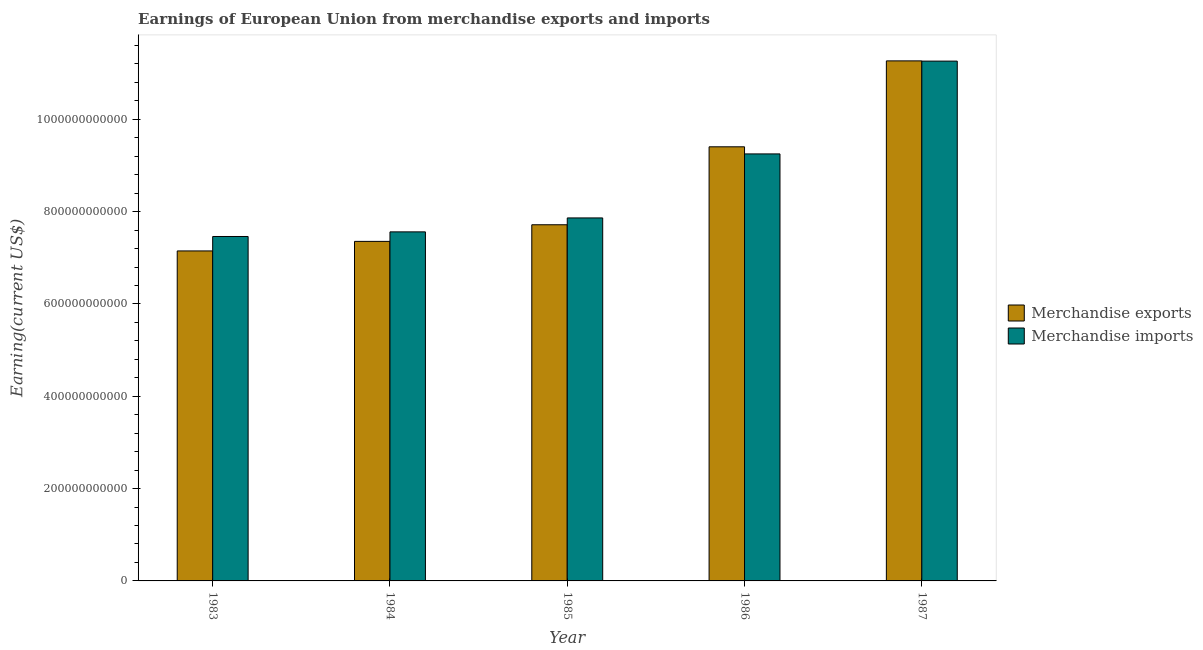Are the number of bars on each tick of the X-axis equal?
Your response must be concise. Yes. How many bars are there on the 4th tick from the left?
Provide a succinct answer. 2. What is the label of the 2nd group of bars from the left?
Keep it short and to the point. 1984. In how many cases, is the number of bars for a given year not equal to the number of legend labels?
Your answer should be very brief. 0. What is the earnings from merchandise imports in 1987?
Offer a very short reply. 1.13e+12. Across all years, what is the maximum earnings from merchandise exports?
Your answer should be very brief. 1.13e+12. Across all years, what is the minimum earnings from merchandise exports?
Keep it short and to the point. 7.15e+11. In which year was the earnings from merchandise exports maximum?
Make the answer very short. 1987. What is the total earnings from merchandise exports in the graph?
Keep it short and to the point. 4.29e+12. What is the difference between the earnings from merchandise imports in 1983 and that in 1985?
Ensure brevity in your answer.  -4.02e+1. What is the difference between the earnings from merchandise exports in 1985 and the earnings from merchandise imports in 1987?
Keep it short and to the point. -3.55e+11. What is the average earnings from merchandise imports per year?
Make the answer very short. 8.68e+11. In the year 1984, what is the difference between the earnings from merchandise exports and earnings from merchandise imports?
Your answer should be very brief. 0. In how many years, is the earnings from merchandise imports greater than 160000000000 US$?
Your answer should be very brief. 5. What is the ratio of the earnings from merchandise imports in 1983 to that in 1986?
Provide a succinct answer. 0.81. Is the earnings from merchandise exports in 1983 less than that in 1984?
Ensure brevity in your answer.  Yes. What is the difference between the highest and the second highest earnings from merchandise exports?
Give a very brief answer. 1.86e+11. What is the difference between the highest and the lowest earnings from merchandise exports?
Provide a short and direct response. 4.12e+11. In how many years, is the earnings from merchandise imports greater than the average earnings from merchandise imports taken over all years?
Offer a terse response. 2. What does the 2nd bar from the left in 1985 represents?
Offer a terse response. Merchandise imports. How many bars are there?
Offer a terse response. 10. What is the difference between two consecutive major ticks on the Y-axis?
Provide a succinct answer. 2.00e+11. Are the values on the major ticks of Y-axis written in scientific E-notation?
Make the answer very short. No. Where does the legend appear in the graph?
Offer a terse response. Center right. How are the legend labels stacked?
Your answer should be very brief. Vertical. What is the title of the graph?
Your response must be concise. Earnings of European Union from merchandise exports and imports. What is the label or title of the X-axis?
Provide a succinct answer. Year. What is the label or title of the Y-axis?
Provide a short and direct response. Earning(current US$). What is the Earning(current US$) in Merchandise exports in 1983?
Offer a very short reply. 7.15e+11. What is the Earning(current US$) in Merchandise imports in 1983?
Your answer should be compact. 7.46e+11. What is the Earning(current US$) of Merchandise exports in 1984?
Give a very brief answer. 7.36e+11. What is the Earning(current US$) of Merchandise imports in 1984?
Make the answer very short. 7.56e+11. What is the Earning(current US$) of Merchandise exports in 1985?
Offer a very short reply. 7.72e+11. What is the Earning(current US$) of Merchandise imports in 1985?
Offer a terse response. 7.86e+11. What is the Earning(current US$) of Merchandise exports in 1986?
Keep it short and to the point. 9.40e+11. What is the Earning(current US$) in Merchandise imports in 1986?
Keep it short and to the point. 9.25e+11. What is the Earning(current US$) of Merchandise exports in 1987?
Offer a very short reply. 1.13e+12. What is the Earning(current US$) of Merchandise imports in 1987?
Keep it short and to the point. 1.13e+12. Across all years, what is the maximum Earning(current US$) in Merchandise exports?
Your answer should be compact. 1.13e+12. Across all years, what is the maximum Earning(current US$) in Merchandise imports?
Provide a succinct answer. 1.13e+12. Across all years, what is the minimum Earning(current US$) of Merchandise exports?
Give a very brief answer. 7.15e+11. Across all years, what is the minimum Earning(current US$) of Merchandise imports?
Offer a very short reply. 7.46e+11. What is the total Earning(current US$) in Merchandise exports in the graph?
Your response must be concise. 4.29e+12. What is the total Earning(current US$) in Merchandise imports in the graph?
Offer a terse response. 4.34e+12. What is the difference between the Earning(current US$) in Merchandise exports in 1983 and that in 1984?
Provide a short and direct response. -2.07e+1. What is the difference between the Earning(current US$) of Merchandise imports in 1983 and that in 1984?
Your response must be concise. -1.00e+1. What is the difference between the Earning(current US$) in Merchandise exports in 1983 and that in 1985?
Provide a short and direct response. -5.67e+1. What is the difference between the Earning(current US$) in Merchandise imports in 1983 and that in 1985?
Offer a terse response. -4.02e+1. What is the difference between the Earning(current US$) in Merchandise exports in 1983 and that in 1986?
Give a very brief answer. -2.26e+11. What is the difference between the Earning(current US$) of Merchandise imports in 1983 and that in 1986?
Provide a succinct answer. -1.79e+11. What is the difference between the Earning(current US$) in Merchandise exports in 1983 and that in 1987?
Ensure brevity in your answer.  -4.12e+11. What is the difference between the Earning(current US$) of Merchandise imports in 1983 and that in 1987?
Give a very brief answer. -3.80e+11. What is the difference between the Earning(current US$) of Merchandise exports in 1984 and that in 1985?
Your answer should be compact. -3.60e+1. What is the difference between the Earning(current US$) of Merchandise imports in 1984 and that in 1985?
Your answer should be compact. -3.02e+1. What is the difference between the Earning(current US$) of Merchandise exports in 1984 and that in 1986?
Your response must be concise. -2.05e+11. What is the difference between the Earning(current US$) in Merchandise imports in 1984 and that in 1986?
Ensure brevity in your answer.  -1.69e+11. What is the difference between the Earning(current US$) of Merchandise exports in 1984 and that in 1987?
Offer a very short reply. -3.91e+11. What is the difference between the Earning(current US$) in Merchandise imports in 1984 and that in 1987?
Keep it short and to the point. -3.70e+11. What is the difference between the Earning(current US$) in Merchandise exports in 1985 and that in 1986?
Give a very brief answer. -1.69e+11. What is the difference between the Earning(current US$) of Merchandise imports in 1985 and that in 1986?
Provide a short and direct response. -1.39e+11. What is the difference between the Earning(current US$) in Merchandise exports in 1985 and that in 1987?
Your response must be concise. -3.55e+11. What is the difference between the Earning(current US$) in Merchandise imports in 1985 and that in 1987?
Give a very brief answer. -3.40e+11. What is the difference between the Earning(current US$) in Merchandise exports in 1986 and that in 1987?
Your answer should be very brief. -1.86e+11. What is the difference between the Earning(current US$) of Merchandise imports in 1986 and that in 1987?
Your response must be concise. -2.01e+11. What is the difference between the Earning(current US$) in Merchandise exports in 1983 and the Earning(current US$) in Merchandise imports in 1984?
Make the answer very short. -4.13e+1. What is the difference between the Earning(current US$) of Merchandise exports in 1983 and the Earning(current US$) of Merchandise imports in 1985?
Offer a very short reply. -7.15e+1. What is the difference between the Earning(current US$) of Merchandise exports in 1983 and the Earning(current US$) of Merchandise imports in 1986?
Offer a terse response. -2.10e+11. What is the difference between the Earning(current US$) in Merchandise exports in 1983 and the Earning(current US$) in Merchandise imports in 1987?
Offer a very short reply. -4.11e+11. What is the difference between the Earning(current US$) in Merchandise exports in 1984 and the Earning(current US$) in Merchandise imports in 1985?
Your answer should be very brief. -5.08e+1. What is the difference between the Earning(current US$) in Merchandise exports in 1984 and the Earning(current US$) in Merchandise imports in 1986?
Your response must be concise. -1.89e+11. What is the difference between the Earning(current US$) in Merchandise exports in 1984 and the Earning(current US$) in Merchandise imports in 1987?
Give a very brief answer. -3.90e+11. What is the difference between the Earning(current US$) of Merchandise exports in 1985 and the Earning(current US$) of Merchandise imports in 1986?
Offer a terse response. -1.53e+11. What is the difference between the Earning(current US$) of Merchandise exports in 1985 and the Earning(current US$) of Merchandise imports in 1987?
Provide a succinct answer. -3.54e+11. What is the difference between the Earning(current US$) of Merchandise exports in 1986 and the Earning(current US$) of Merchandise imports in 1987?
Provide a short and direct response. -1.86e+11. What is the average Earning(current US$) of Merchandise exports per year?
Offer a terse response. 8.58e+11. What is the average Earning(current US$) in Merchandise imports per year?
Your answer should be compact. 8.68e+11. In the year 1983, what is the difference between the Earning(current US$) in Merchandise exports and Earning(current US$) in Merchandise imports?
Ensure brevity in your answer.  -3.13e+1. In the year 1984, what is the difference between the Earning(current US$) in Merchandise exports and Earning(current US$) in Merchandise imports?
Your answer should be compact. -2.06e+1. In the year 1985, what is the difference between the Earning(current US$) of Merchandise exports and Earning(current US$) of Merchandise imports?
Give a very brief answer. -1.48e+1. In the year 1986, what is the difference between the Earning(current US$) of Merchandise exports and Earning(current US$) of Merchandise imports?
Offer a very short reply. 1.54e+1. In the year 1987, what is the difference between the Earning(current US$) of Merchandise exports and Earning(current US$) of Merchandise imports?
Make the answer very short. 5.06e+08. What is the ratio of the Earning(current US$) of Merchandise exports in 1983 to that in 1984?
Your answer should be very brief. 0.97. What is the ratio of the Earning(current US$) in Merchandise imports in 1983 to that in 1984?
Your answer should be very brief. 0.99. What is the ratio of the Earning(current US$) of Merchandise exports in 1983 to that in 1985?
Keep it short and to the point. 0.93. What is the ratio of the Earning(current US$) in Merchandise imports in 1983 to that in 1985?
Make the answer very short. 0.95. What is the ratio of the Earning(current US$) in Merchandise exports in 1983 to that in 1986?
Give a very brief answer. 0.76. What is the ratio of the Earning(current US$) in Merchandise imports in 1983 to that in 1986?
Your response must be concise. 0.81. What is the ratio of the Earning(current US$) in Merchandise exports in 1983 to that in 1987?
Provide a short and direct response. 0.63. What is the ratio of the Earning(current US$) of Merchandise imports in 1983 to that in 1987?
Give a very brief answer. 0.66. What is the ratio of the Earning(current US$) of Merchandise exports in 1984 to that in 1985?
Offer a very short reply. 0.95. What is the ratio of the Earning(current US$) of Merchandise imports in 1984 to that in 1985?
Keep it short and to the point. 0.96. What is the ratio of the Earning(current US$) of Merchandise exports in 1984 to that in 1986?
Give a very brief answer. 0.78. What is the ratio of the Earning(current US$) in Merchandise imports in 1984 to that in 1986?
Offer a terse response. 0.82. What is the ratio of the Earning(current US$) of Merchandise exports in 1984 to that in 1987?
Your response must be concise. 0.65. What is the ratio of the Earning(current US$) of Merchandise imports in 1984 to that in 1987?
Your response must be concise. 0.67. What is the ratio of the Earning(current US$) in Merchandise exports in 1985 to that in 1986?
Your answer should be compact. 0.82. What is the ratio of the Earning(current US$) in Merchandise imports in 1985 to that in 1986?
Offer a very short reply. 0.85. What is the ratio of the Earning(current US$) in Merchandise exports in 1985 to that in 1987?
Make the answer very short. 0.68. What is the ratio of the Earning(current US$) of Merchandise imports in 1985 to that in 1987?
Provide a short and direct response. 0.7. What is the ratio of the Earning(current US$) of Merchandise exports in 1986 to that in 1987?
Offer a terse response. 0.83. What is the ratio of the Earning(current US$) of Merchandise imports in 1986 to that in 1987?
Provide a short and direct response. 0.82. What is the difference between the highest and the second highest Earning(current US$) in Merchandise exports?
Make the answer very short. 1.86e+11. What is the difference between the highest and the second highest Earning(current US$) of Merchandise imports?
Your response must be concise. 2.01e+11. What is the difference between the highest and the lowest Earning(current US$) in Merchandise exports?
Provide a short and direct response. 4.12e+11. What is the difference between the highest and the lowest Earning(current US$) of Merchandise imports?
Offer a terse response. 3.80e+11. 